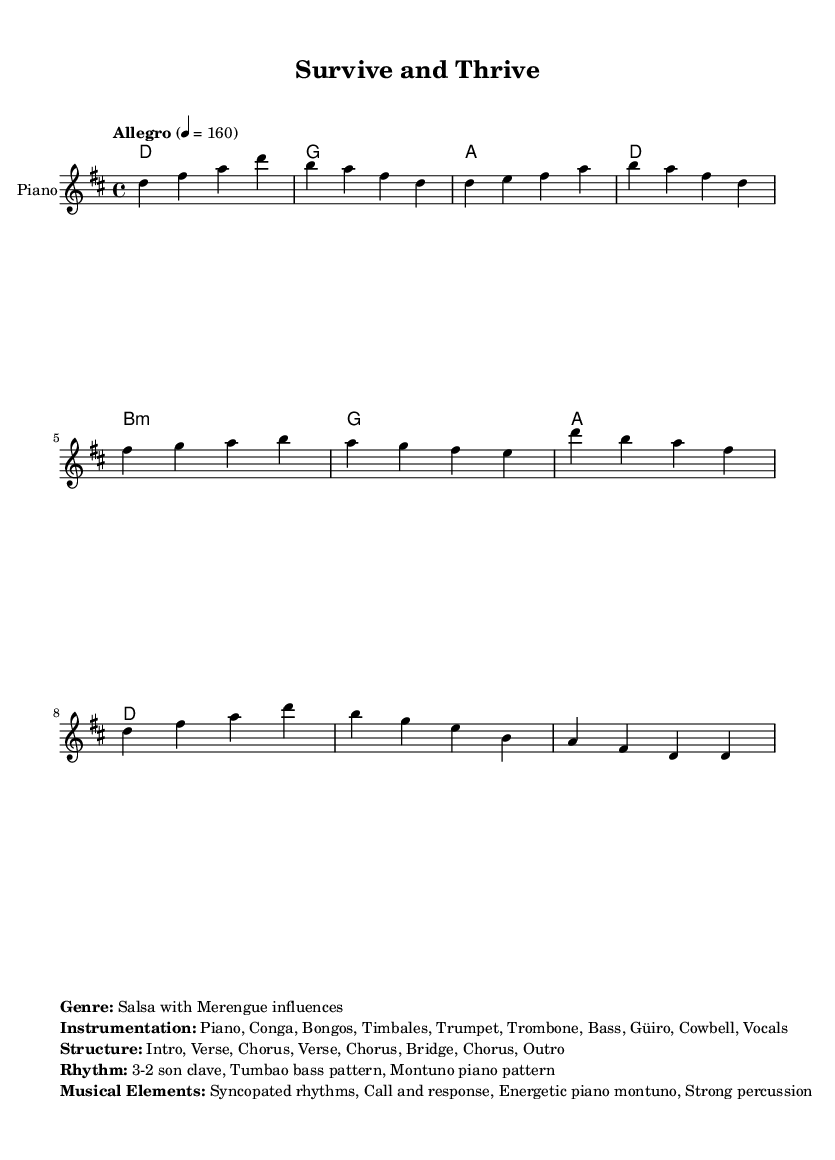What is the key signature of this music? The key signature is indicated at the beginning of the score, where there are two sharps (F# and C#) present.
Answer: D major What is the time signature of the piece? The time signature is located near the beginning of the score, shown as a fraction representing beats per measure. It is indicated as 4/4, meaning there are four beats in each measure and a quarter note receives one beat.
Answer: 4/4 What is the tempo marking indicated in the score? The tempo marking appears written above the staff, specifying the speed of the piece. It's noted as "Allegro" and the exact beats per minute (bpm) indication is 160.
Answer: Allegro, 160 How many sections are there in the structure of the song? The structure is outlined in the score with terms indicating the arrangement. Counting the mentioned parts: Intro, Verse, Chorus, Verse, Chorus, Bridge, Chorus, and Outro results in a total of 8 sections.
Answer: 8 What are the primary instruments indicated in the ensemble? The instruments used are listed directly in the markup section of the score and include Piano, Conga, Bongos, Timbales, Trumpet, Trombone, Bass, Güiro, Cowbell, and Vocals. Identifying these provides the instrumentation for the piece.
Answer: Piano, Conga, Bongos, Timbales, Trumpet, Trombone, Bass, Güiro, Cowbell, Vocals What rhythmic pattern is primarily used in the salsa rhythm? The score notes that it employs the "3-2 son clave" rhythm pattern, a signature aspect of salsa music, highlighting the unique rhythmic feel typical of this genre.
Answer: 3-2 son clave 